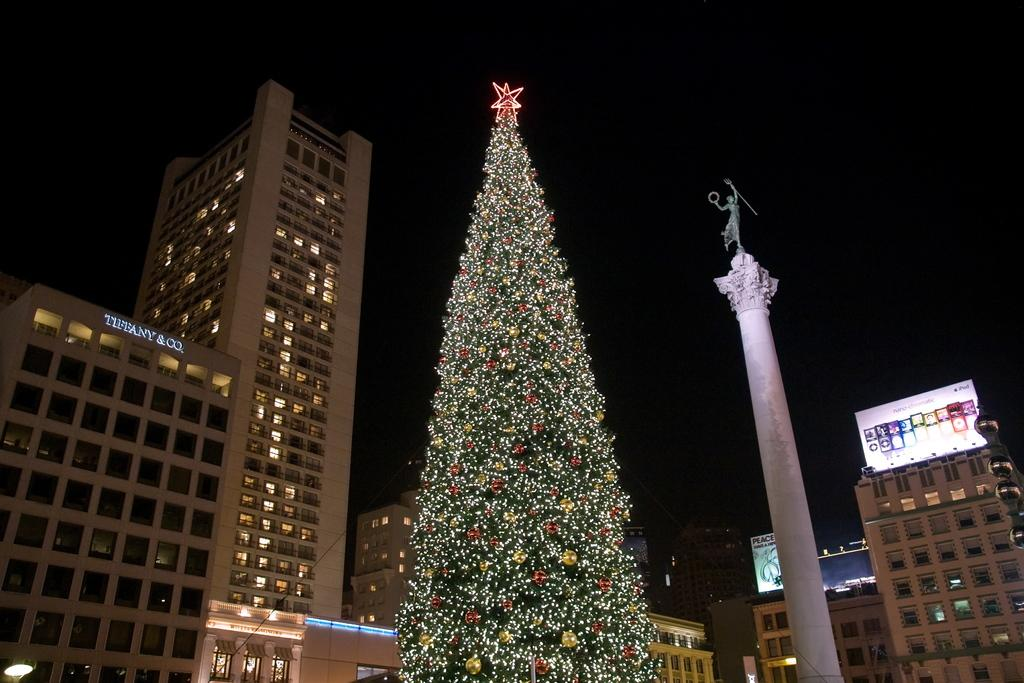What type of tree is in the image? There is a Christmas tree in the image. What architectural feature can be seen in the image? There is a pillar in the image. What type of object is in the image that represents a person or thing? There is a statue in the image. What type of decoration is in the image? There are banners in the image. What type of illumination is in the image? There are lights in the image. What type of structures are in the image? There are buildings with windows in the image. What is the color of the background in the image? The background of the image is dark. Where is the rake located in the image? There is no rake present in the image. What type of cave is depicted in the image? There is no cave present in the image. 